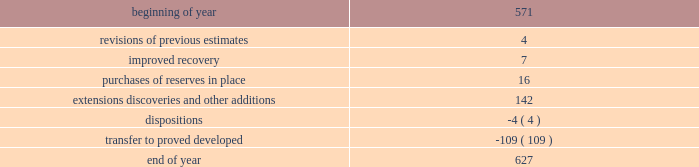Changes in proved undeveloped reserves as of december 31 , 2013 , 627 mmboe of proved undeveloped reserves were reported , an increase of 56 mmboe from december 31 , 2012 .
The table shows changes in total proved undeveloped reserves for 2013 : ( mmboe ) .
Significant additions to proved undeveloped reserves during 2013 included 72 mmboe in the eagle ford and 49 mmboe in the bakken shale plays due to development drilling .
Transfers from proved undeveloped to proved developed reserves included 57 mmboe in the eagle ford , 18 mmboe in the bakken and 7 mmboe in the oklahoma resource basins due to producing wells .
Costs incurred in 2013 , 2012 and 2011 relating to the development of proved undeveloped reserves , were $ 2536 million , $ 1995 million and $ 1107 million .
A total of 59 mmboe was booked as a result of reliable technology .
Technologies included statistical analysis of production performance , decline curve analysis , rate transient analysis , reservoir simulation and volumetric analysis .
The statistical nature of production performance coupled with highly certain reservoir continuity or quality within the reliable technology areas and sufficient proved undeveloped locations establish the reasonable certainty criteria required for booking reserves .
Projects can remain in proved undeveloped reserves for extended periods in certain situations such as large development projects which take more than five years to complete , or the timing of when additional gas compression is needed .
Of the 627 mmboe of proved undeveloped reserves at december 31 , 2013 , 24 percent of the volume is associated with projects that have been included in proved reserves for more than five years .
The majority of this volume is related to a compression project in e.g .
That was sanctioned by our board of directors in 2004 .
The timing of the installation of compression is being driven by the reservoir performance with this project intended to maintain maximum production levels .
Performance of this field since the board sanctioned the project has far exceeded expectations .
Estimates of initial dry gas in place increased by roughly 10 percent between 2004 and 2010 .
During 2012 , the compression project received the approval of the e.g .
Government , allowing design and planning work to progress towards implementation , with completion expected by mid-2016 .
The other component of alba proved undeveloped reserves is an infill well approved in 2013 and to be drilled late 2014 .
Proved undeveloped reserves for the north gialo development , located in the libyan sahara desert , were booked for the first time as proved undeveloped reserves in 2010 .
This development , which is anticipated to take more than five years to be developed , is being executed by the operator and encompasses a continuous drilling program including the design , fabrication and installation of extensive liquid handling and gas recycling facilities .
Anecdotal evidence from similar development projects in the region led to an expected project execution of more than five years from the time the reserves were initially booked .
Interruptions associated with the civil unrest in 2011 and third-party labor strikes in 2013 have extended the project duration .
There are no other significant undeveloped reserves expected to be developed more than five years after their original booking .
As of december 31 , 2013 , future development costs estimated to be required for the development of proved undeveloped liquid hydrocarbon , natural gas and synthetic crude oil reserves related to continuing operations for the years 2014 through 2018 are projected to be $ 2894 million , $ 2567 million , $ 2020 million , $ 1452 million and $ 575 million .
The timing of future projects and estimated future development costs relating to the development of proved undeveloped liquid hydrocarbon , natural gas and synthetic crude oil reserves are forward-looking statements and are based on a number of assumptions , including ( among others ) commodity prices , presently known physical data concerning size and character of the reservoirs , economic recoverability , technology developments , future drilling success , industry economic conditions , levels of cash flow from operations , production experience and other operating considerations .
To the extent these assumptions prove inaccurate , actual recoveries , timing and development costs could be different than current estimates. .
What were total costs incurred in 2013 , 2012 and 2011 relating to the development of proved undeveloped reserves , in $ millions? 
Computations: ((2536 + 1995) + 1107)
Answer: 5638.0. 